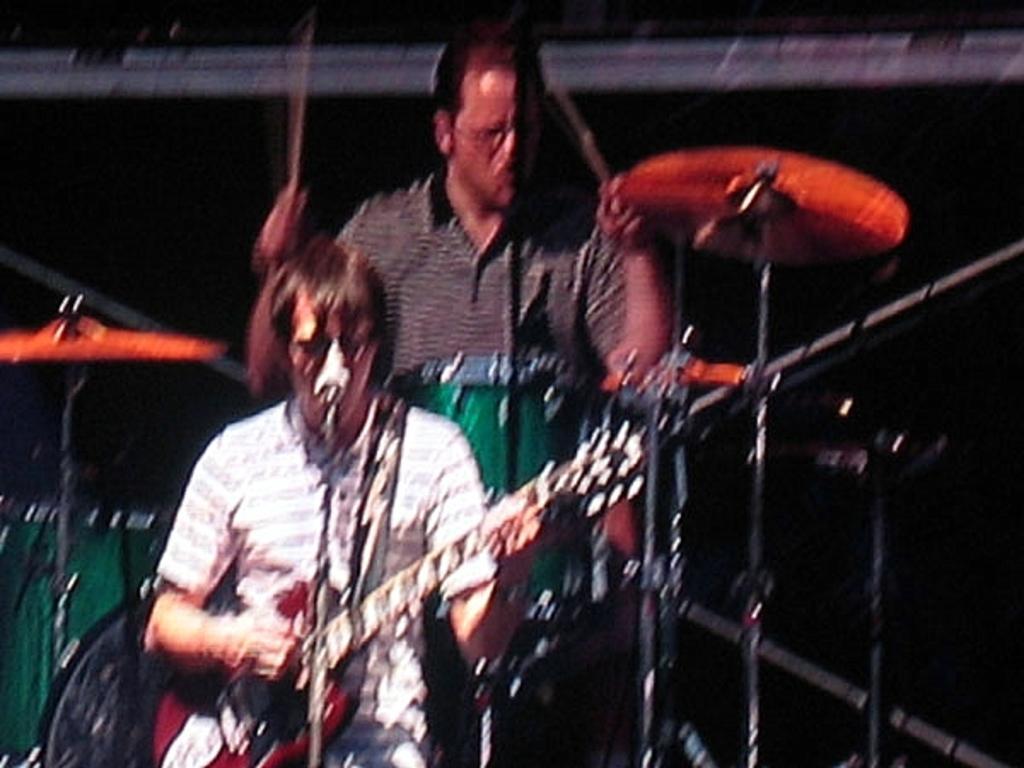Could you give a brief overview of what you see in this image? In this image, two peoples are playing a musical instruments. There are microphones in the image. 